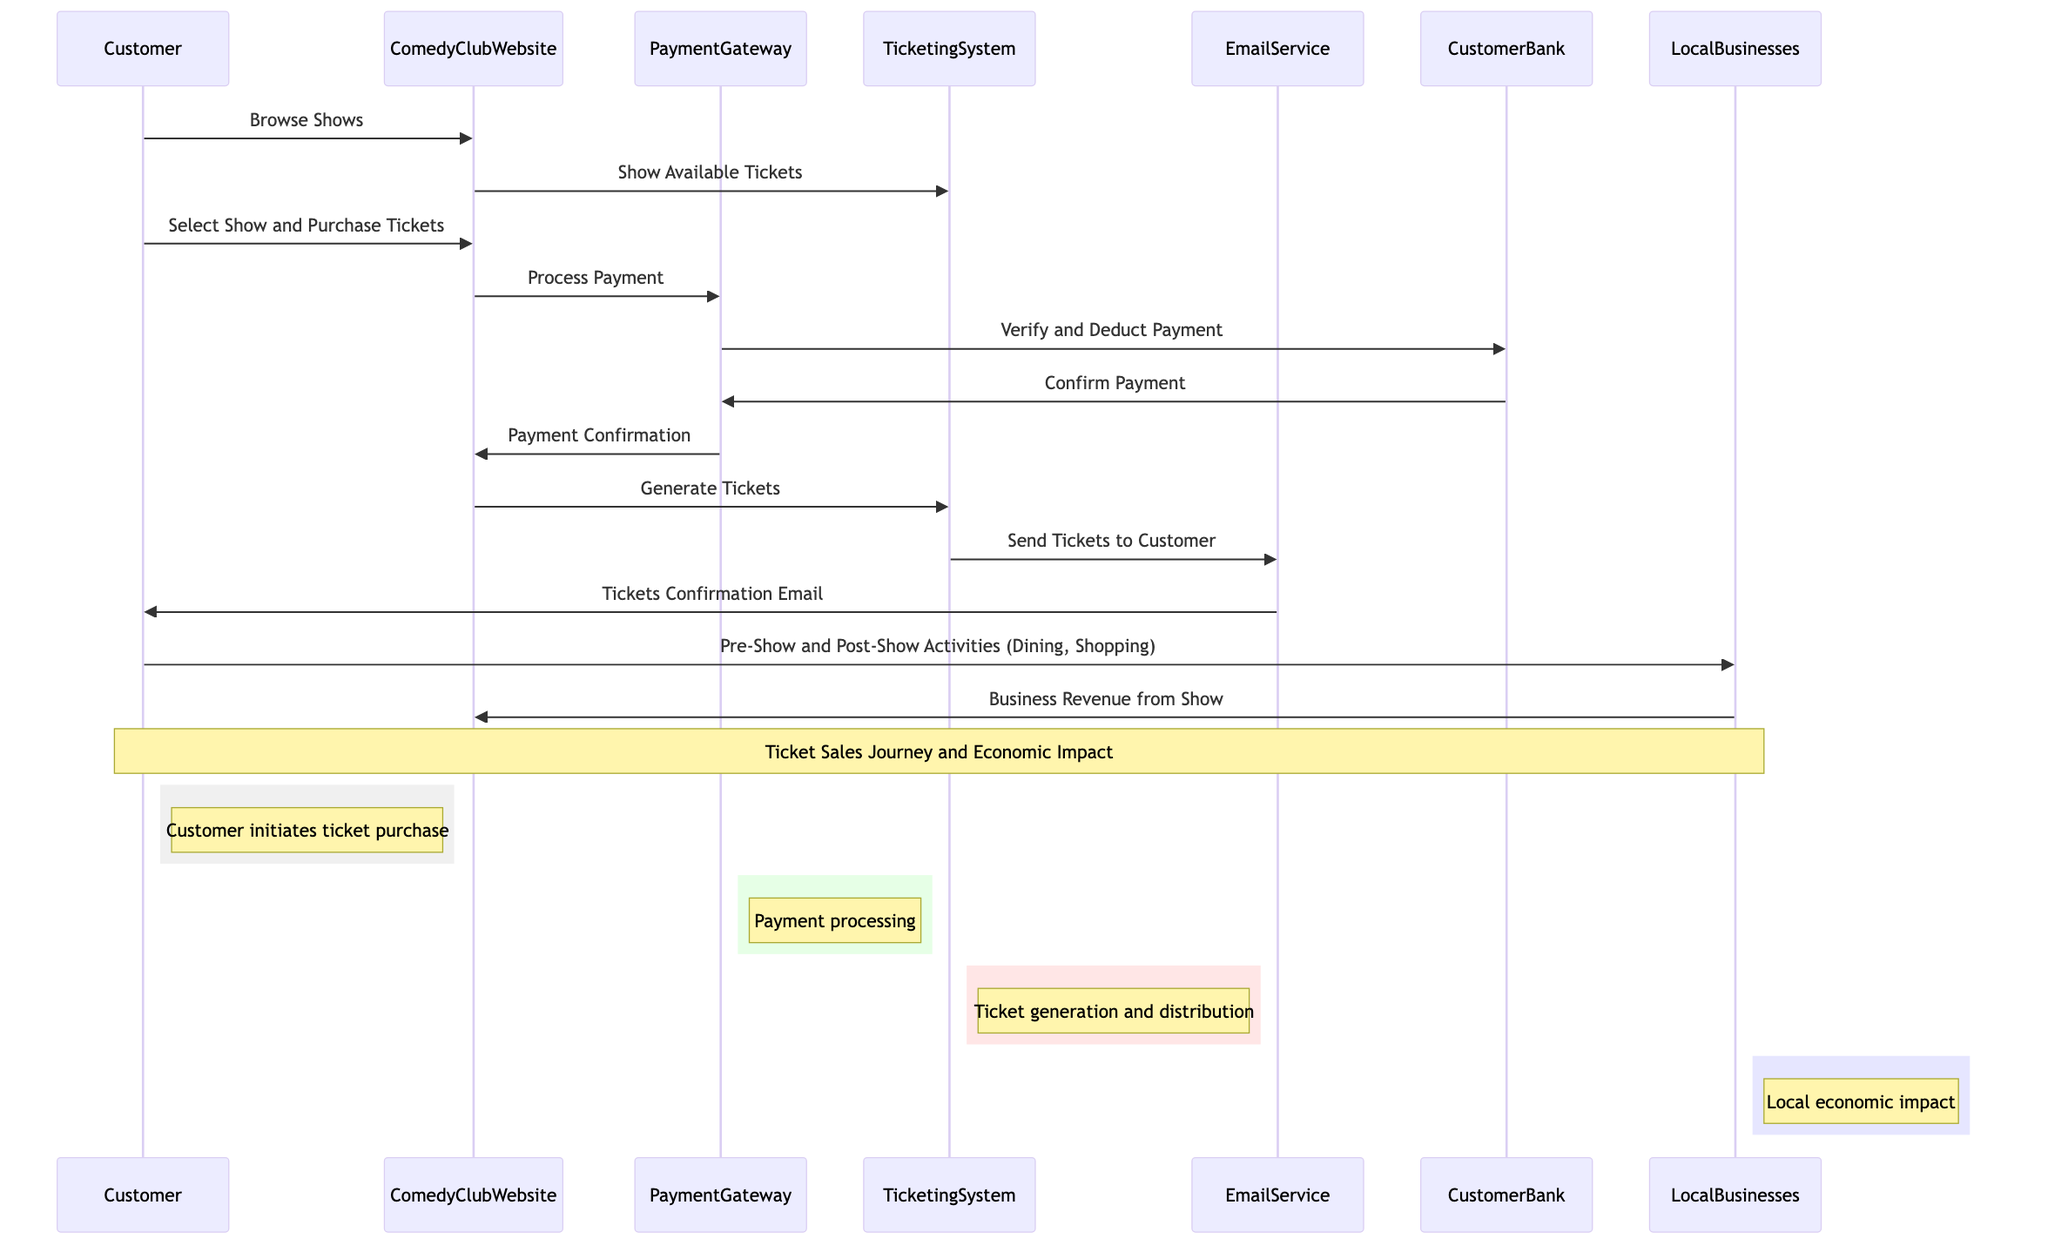What is the first action a customer takes in the ticket sales journey? The first action is "Browse Shows," initiated by the Customer interacting with the ComedyClubWebsite.
Answer: Browse Shows How many external entities are represented in the diagram? The diagram shows two external entities: CustomerBank and LocalBusinesses, which are clearly labeled as external entities.
Answer: 2 What system does the ComedyClubWebsite communicate with to process payments? The ComedyClubWebsite communicates with the PaymentGateway to handle the payment processing after a customer decides to purchase tickets.
Answer: PaymentGateway What is the final action that takes place after a customer receives their tickets? The final action involves the LocalBusinesses receiving revenue from the show, which signifies their economic gain related to the ticket sales.
Answer: Business Revenue from Show Which entity is responsible for generating tickets? The entity responsible for generating tickets is the TicketingSystem, which receives a request from the ComedyClubWebsite after payment confirmation.
Answer: TicketingSystem What action do customers take related to LocalBusinesses? Customers engage in "Pre-Show and Post-Show Activities," which involve dining and shopping around the comedy show events.
Answer: Pre-Show and Post-Show Activities Which system sends a confirmation email to the customer? The EmailService is tasked with sending the tickets confirmation email to the Customer after the ticket generation process.
Answer: EmailService What type of impact is noted over the Customer and LocalBusinesses? The note indicates "Ticket Sales Journey and Economic Impact," highlighting the relationship between ticket sales and local economic benefits experienced by businesses.
Answer: Ticket Sales Journey and Economic Impact 